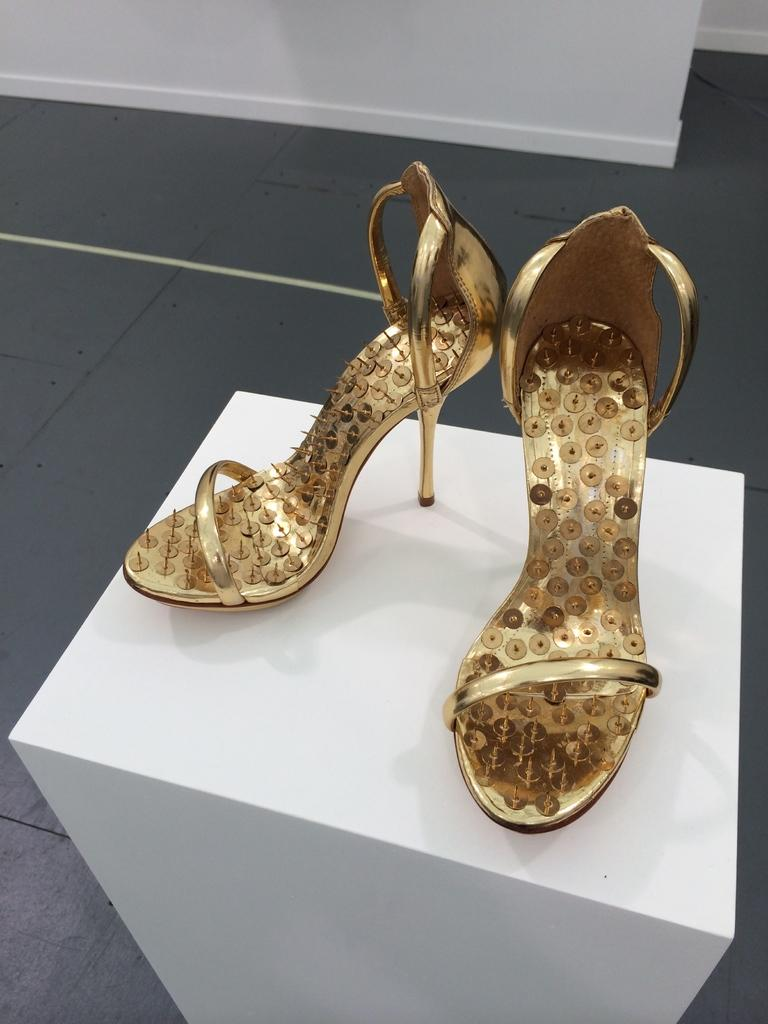What type of footwear is in the image? There is footwear in the image. What color is the footwear? The footwear is brown in color. Where is the footwear placed in the image? The footwear is on a white surface. What color is the floor visible in the image? The floor is grey in color. What color is the wall visible in the image? The wall is white in color. Can you see a bear crushing the footwear in the image? No, there is no bear or any sign of crushing in the image; it only shows footwear on a white surface. 